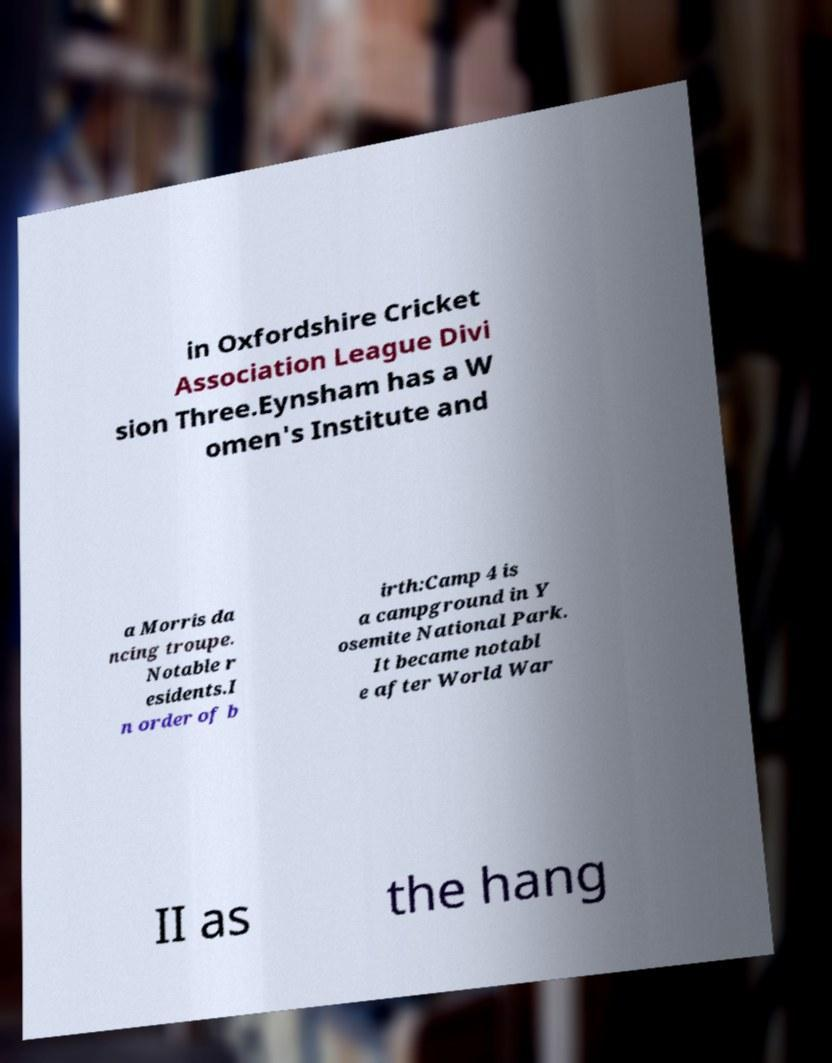Could you extract and type out the text from this image? in Oxfordshire Cricket Association League Divi sion Three.Eynsham has a W omen's Institute and a Morris da ncing troupe. Notable r esidents.I n order of b irth:Camp 4 is a campground in Y osemite National Park. It became notabl e after World War II as the hang 